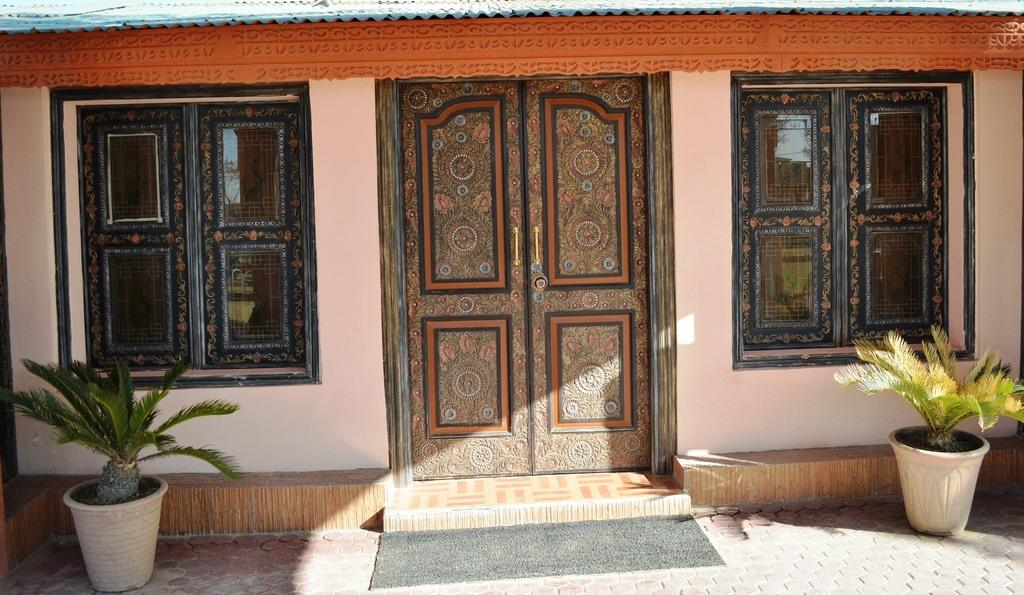What type of plants can be seen in the image? There are houseplants in the image. What architectural features are visible in the image? There are windows, a door, and a doormat visible in the image. What type of structure is present in the image? There is a house in the image. Can you describe the lighting conditions in the image? The image was likely taken during the day, as there is sufficient natural light. What is the existence of the stem in the image? There is no mention of a stem in the provided facts, and therefore it cannot be determined if a stem is present in the image. How many bits can be seen in the image? There is no reference to any "bits" in the image, so it is impossible to answer this question. 